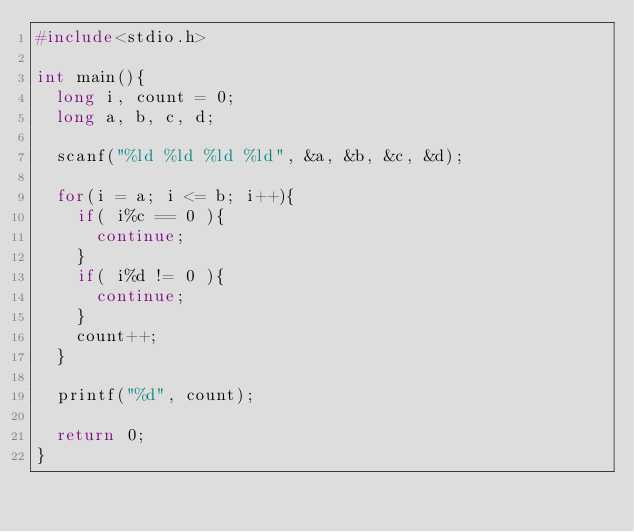<code> <loc_0><loc_0><loc_500><loc_500><_C_>#include<stdio.h>
 
int main(){
  long i, count = 0;
  long a, b, c, d;
  
  scanf("%ld %ld %ld %ld", &a, &b, &c, &d);
  
  for(i = a; i <= b; i++){
    if( i%c == 0 ){
      continue;
    }
    if( i%d != 0 ){
      continue;
    }
    count++;
  }
  
  printf("%d", count);
  
  return 0;
}</code> 